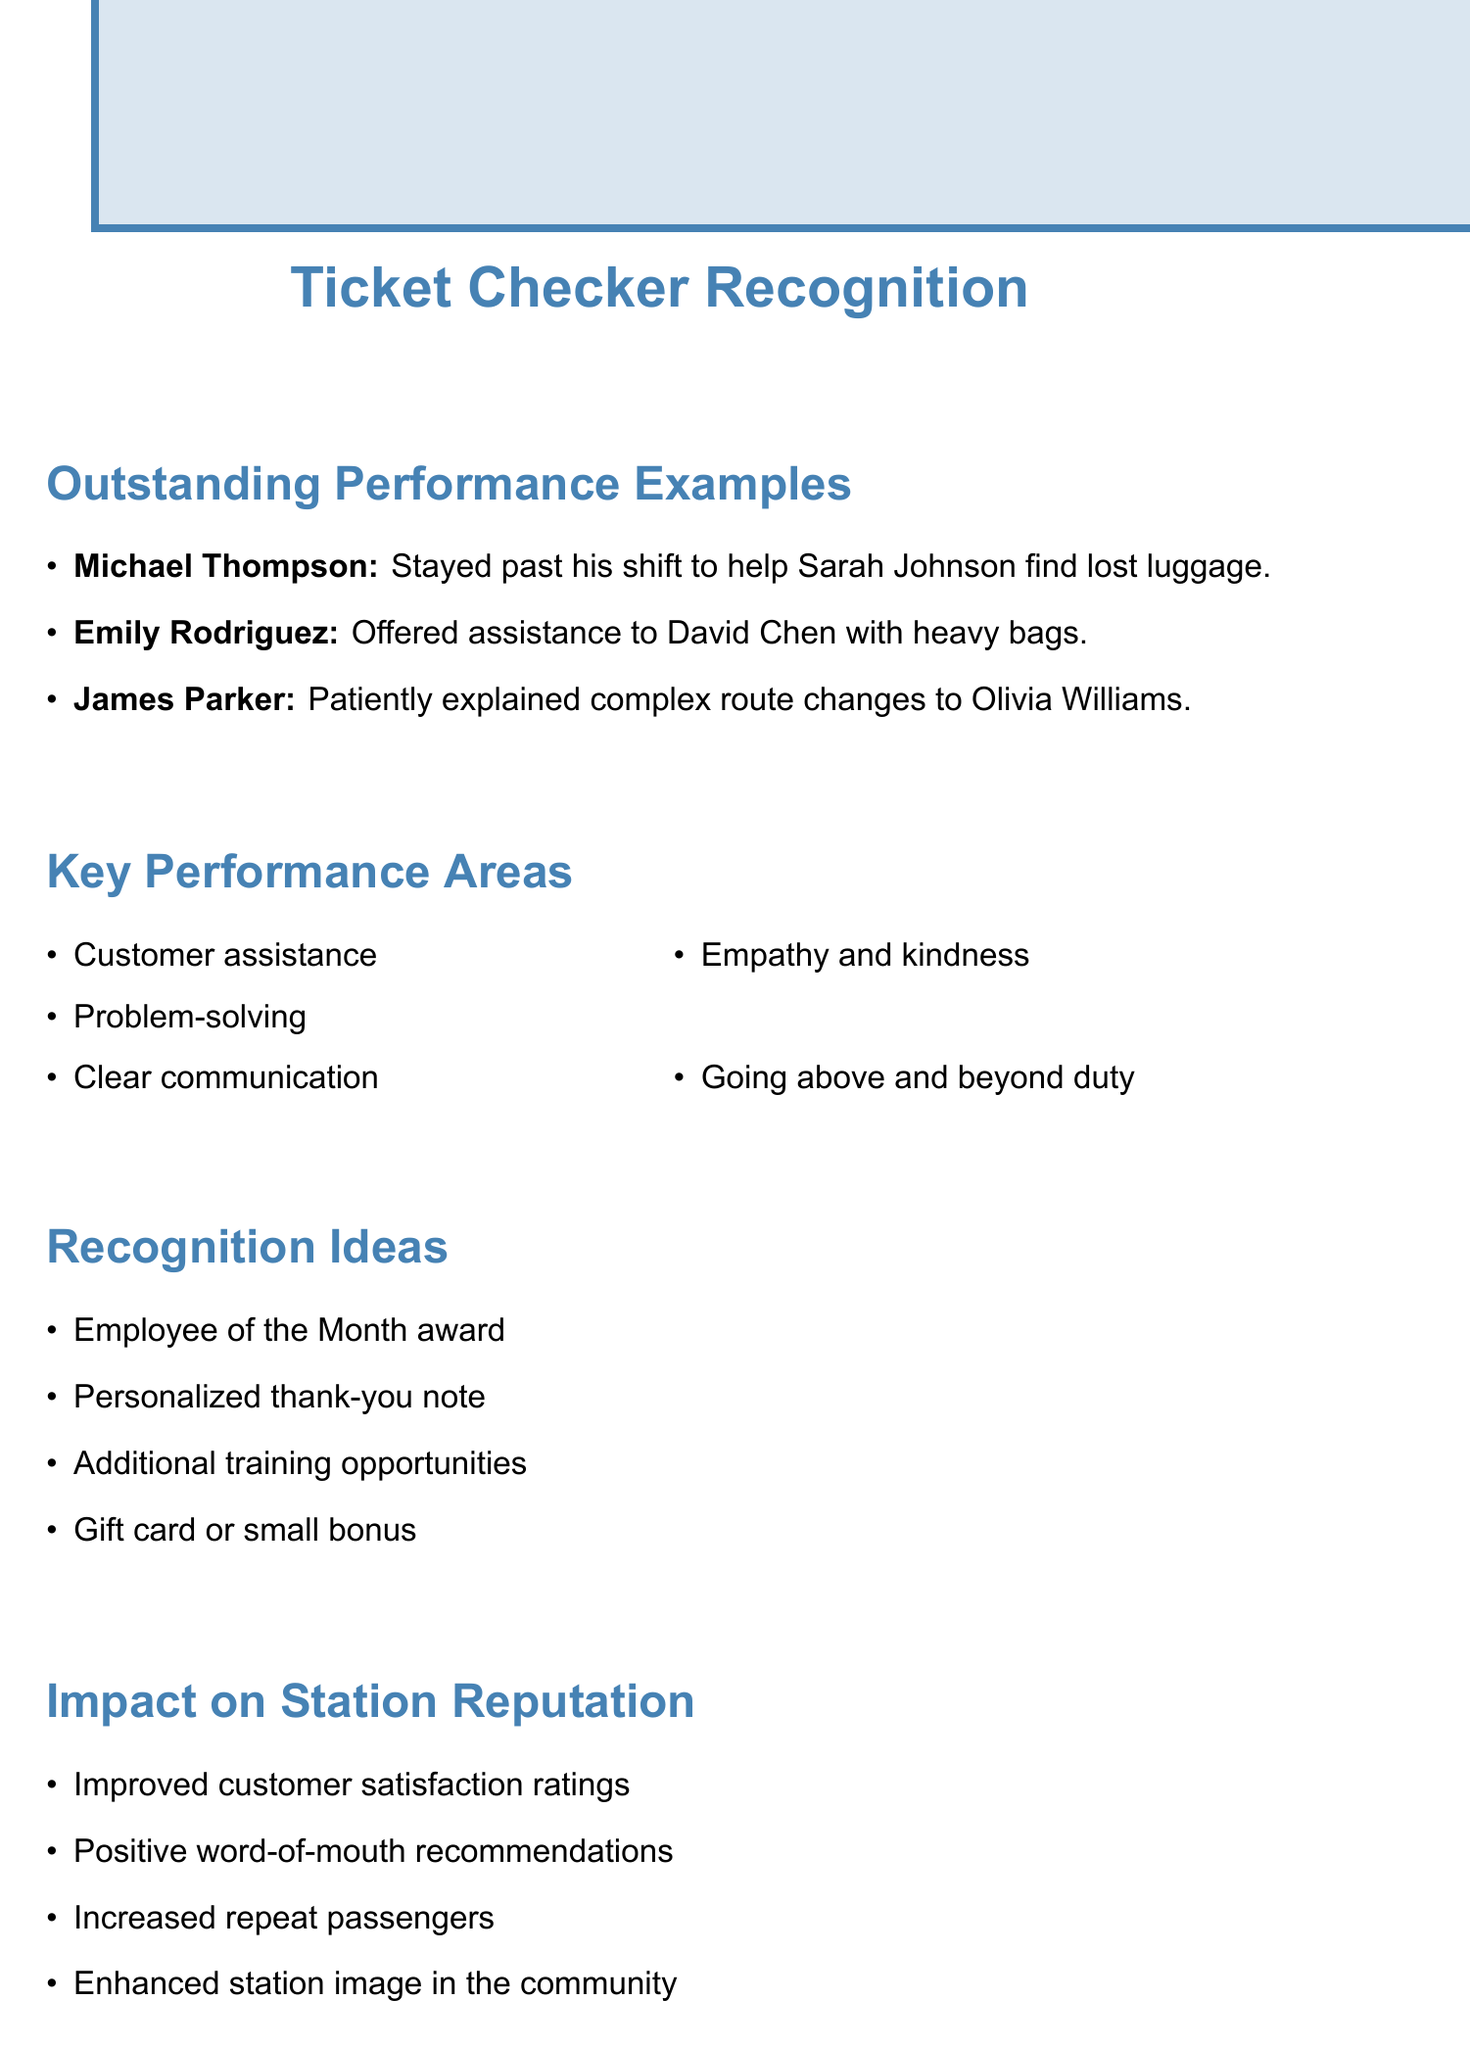What did Michael Thompson help Sarah Johnson with? Michael Thompson helped Sarah Johnson find her lost luggage, as noted in the feedback.
Answer: lost luggage Who assisted David Chen with his bags? The feedback states that Emily Rodriguez offered assistance to David Chen with his heavy bags.
Answer: Emily Rodriguez What performance area involves helping passengers with baggage? The area related to assisting passengers with baggage falls under "Customer assistance."
Answer: Customer assistance How did James Parker contribute to Olivia Williams' journey? James Parker explained complex route changes to Olivia Williams, which was mentioned in the feedback.
Answer: explained route changes What is one suggested recognition idea for outstanding employees? The document lists "Employee of the Month award" as a suggested recognition idea for celebrating outstanding employees.
Answer: Employee of the Month award What impact resulted from improved customer service? The document mentions that improved customer service led to "Improved customer satisfaction ratings."
Answer: Improved customer satisfaction ratings How many highlighted key performance areas are listed in the document? The document outlines five key performance areas related to ticket checkers' roles.
Answer: five What training topic is suggested for enhancing customer service skills? "Advanced customer service techniques" is one of the suggested training topics mentioned in the document.
Answer: Advanced customer service techniques 